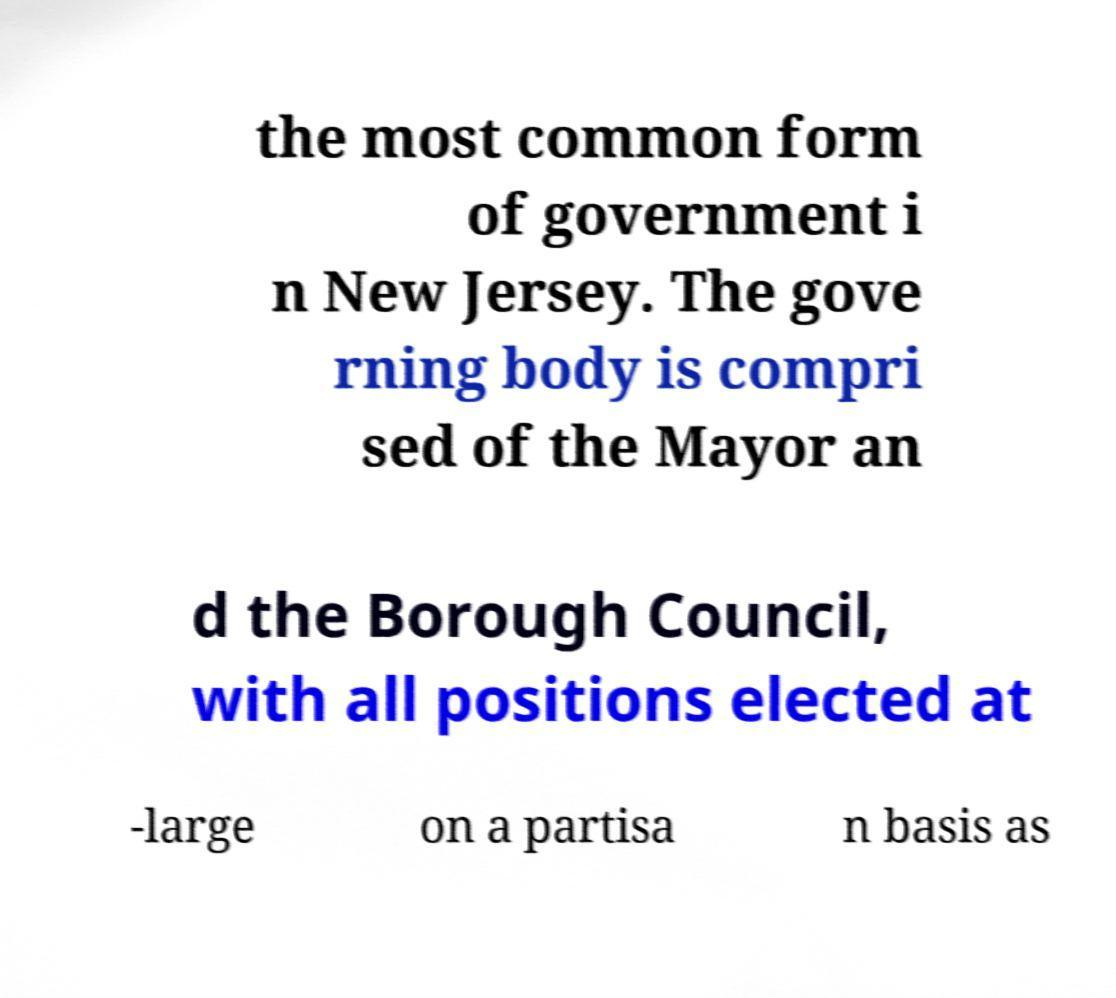Could you extract and type out the text from this image? the most common form of government i n New Jersey. The gove rning body is compri sed of the Mayor an d the Borough Council, with all positions elected at -large on a partisa n basis as 